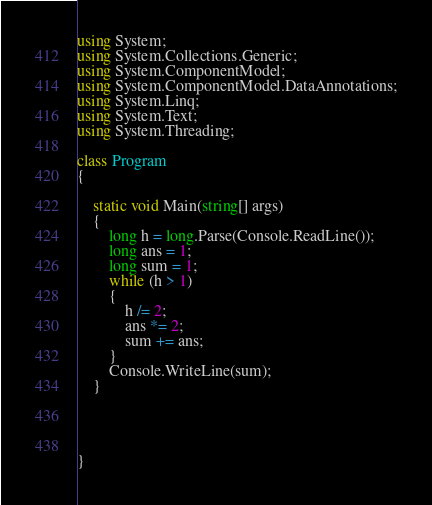Convert code to text. <code><loc_0><loc_0><loc_500><loc_500><_C#_>using System;
using System.Collections.Generic;
using System.ComponentModel;
using System.ComponentModel.DataAnnotations;
using System.Linq;
using System.Text;
using System.Threading;

class Program
{

    static void Main(string[] args)
    {
        long h = long.Parse(Console.ReadLine());
        long ans = 1;
        long sum = 1;
        while (h > 1)
        {
            h /= 2;
            ans *= 2;
            sum += ans;
        }
        Console.WriteLine(sum);
    }




}</code> 